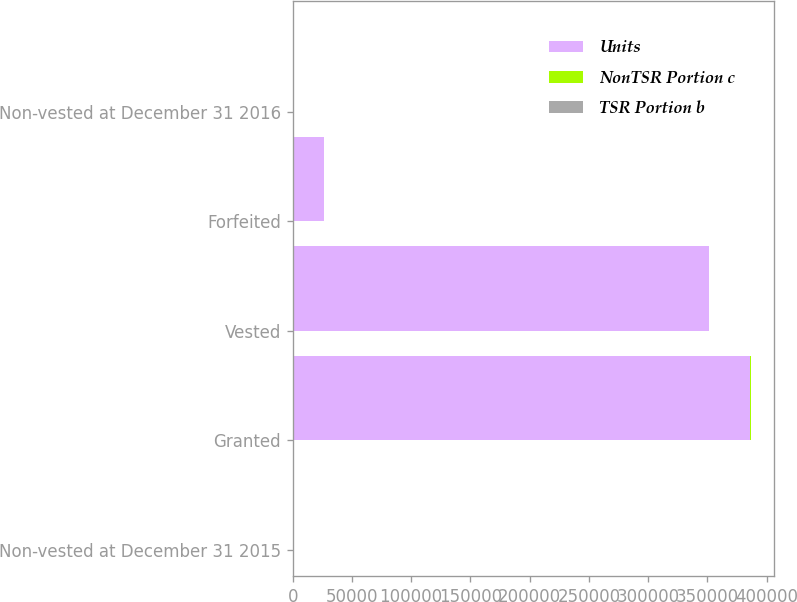Convert chart to OTSL. <chart><loc_0><loc_0><loc_500><loc_500><stacked_bar_chart><ecel><fcel>Non-vested at December 31 2015<fcel>Granted<fcel>Vested<fcel>Forfeited<fcel>Non-vested at December 31 2016<nl><fcel>Units<fcel>61.03<fcel>386400<fcel>351230<fcel>26372<fcel>61.03<nl><fcel>NonTSR Portion c<fcel>45.26<fcel>83.16<fcel>55.16<fcel>48.48<fcel>55.45<nl><fcel>TSR Portion b<fcel>58.08<fcel>72.1<fcel>57.96<fcel>61.03<fcel>63.03<nl></chart> 